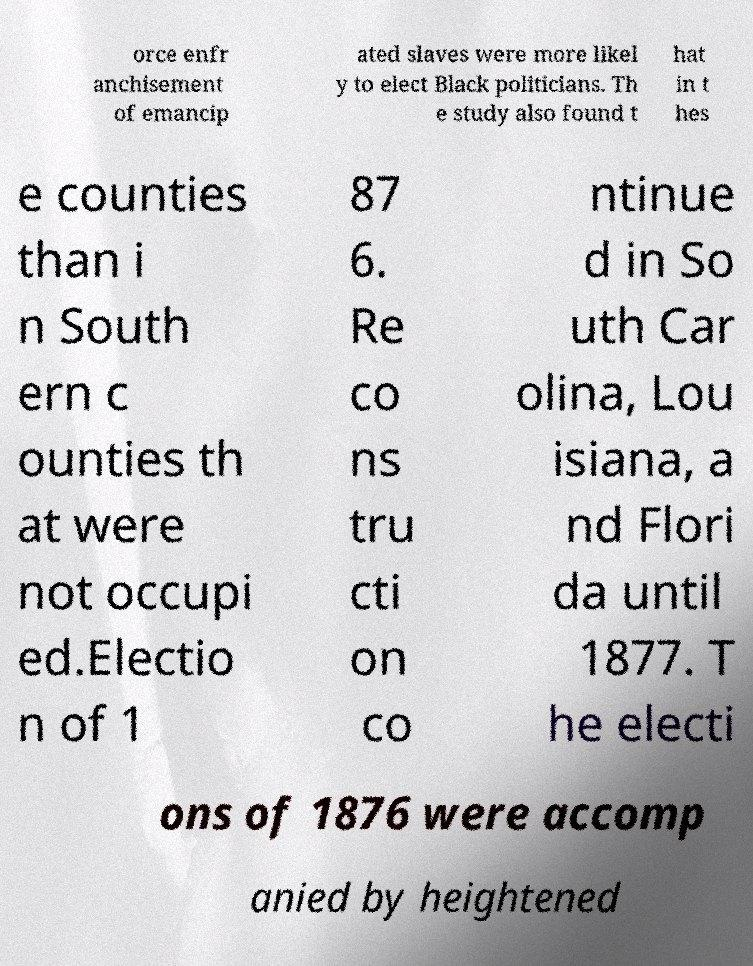Can you read and provide the text displayed in the image?This photo seems to have some interesting text. Can you extract and type it out for me? orce enfr anchisement of emancip ated slaves were more likel y to elect Black politicians. Th e study also found t hat in t hes e counties than i n South ern c ounties th at were not occupi ed.Electio n of 1 87 6. Re co ns tru cti on co ntinue d in So uth Car olina, Lou isiana, a nd Flori da until 1877. T he electi ons of 1876 were accomp anied by heightened 